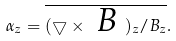Convert formula to latex. <formula><loc_0><loc_0><loc_500><loc_500>\alpha _ { z } = \overline { ( \bigtriangledown \times \emph { B } ) _ { z } / B _ { z } } .</formula> 